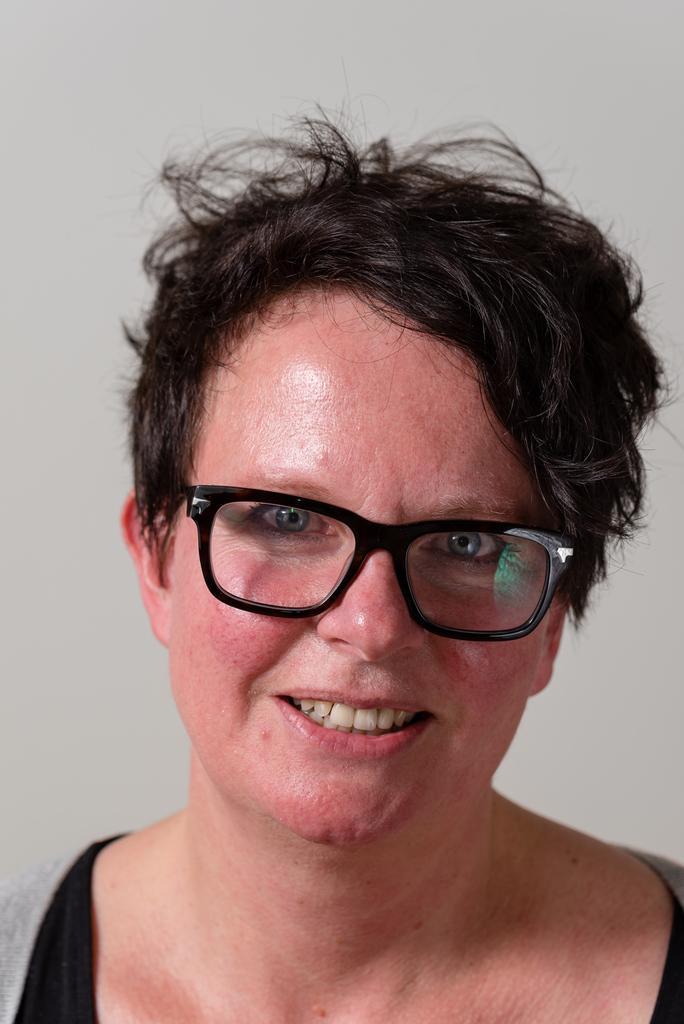Could you give a brief overview of what you see in this image? In this picture we can see a woman smiling, she wore spectacles, there is a plane background. 